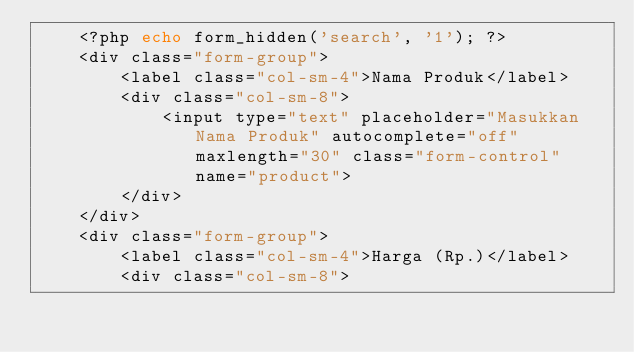<code> <loc_0><loc_0><loc_500><loc_500><_PHP_>    <?php echo form_hidden('search', '1'); ?>
    <div class="form-group">
        <label class="col-sm-4">Nama Produk</label>
        <div class="col-sm-8">
            <input type="text" placeholder="Masukkan Nama Produk" autocomplete="off" maxlength="30" class="form-control" name="product">
        </div>
    </div>
    <div class="form-group">
        <label class="col-sm-4">Harga (Rp.)</label>
        <div class="col-sm-8"></code> 